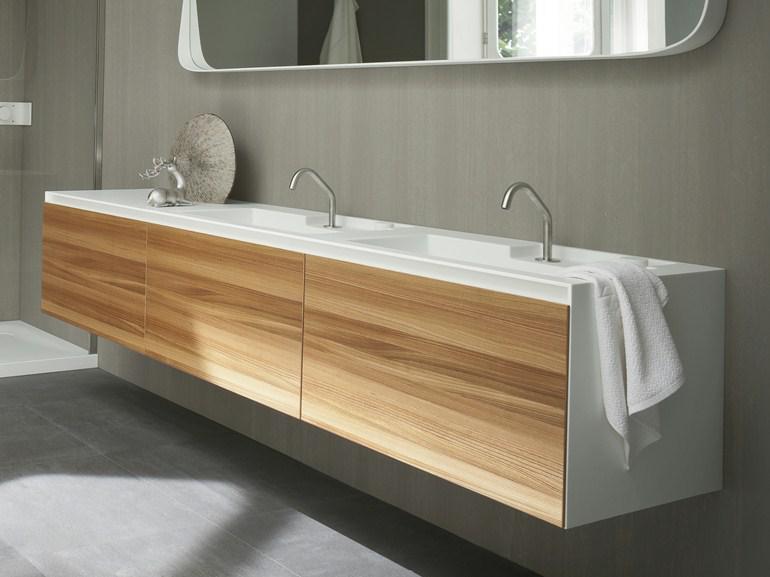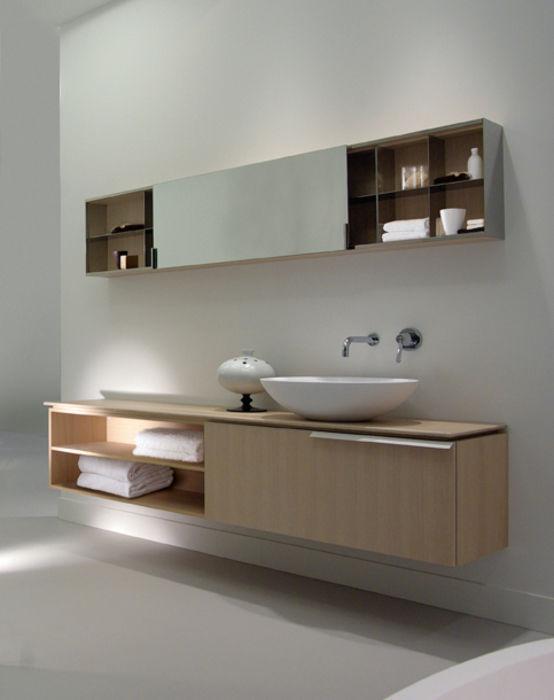The first image is the image on the left, the second image is the image on the right. Given the left and right images, does the statement "In one image, a wide box-like vanity attached to the wall has a white sink installed at one end, while the opposite end is open, showing towel storage." hold true? Answer yes or no. Yes. The first image is the image on the left, the second image is the image on the right. For the images shown, is this caption "An image shows a wall-mounted beige vanity with opened shelf section containing stacks of white towels." true? Answer yes or no. Yes. 